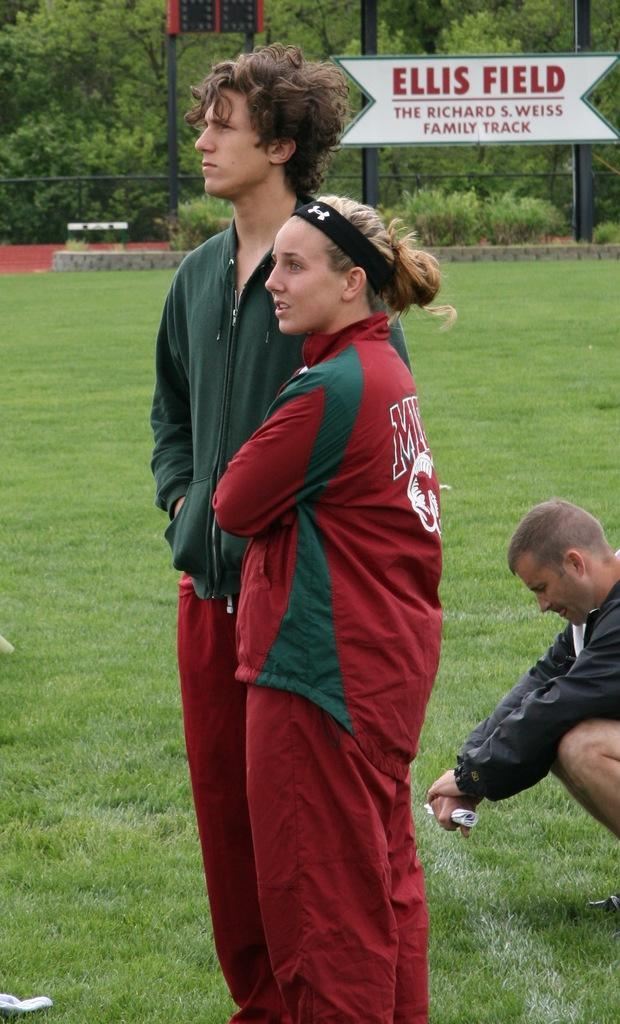How many people are standing in the image? There is a man and a woman standing in the image. What is the position of the other man in the image? There is a man sitting on the ground in the image. What can be seen in the background of the image? Iron poles, an information board, and trees are present in the background of the image. What type of laborer is working near the prison in the image? There is no prison or laborer present in the image. Is there a fire visible in the image? No, there is no fire visible in the image. 